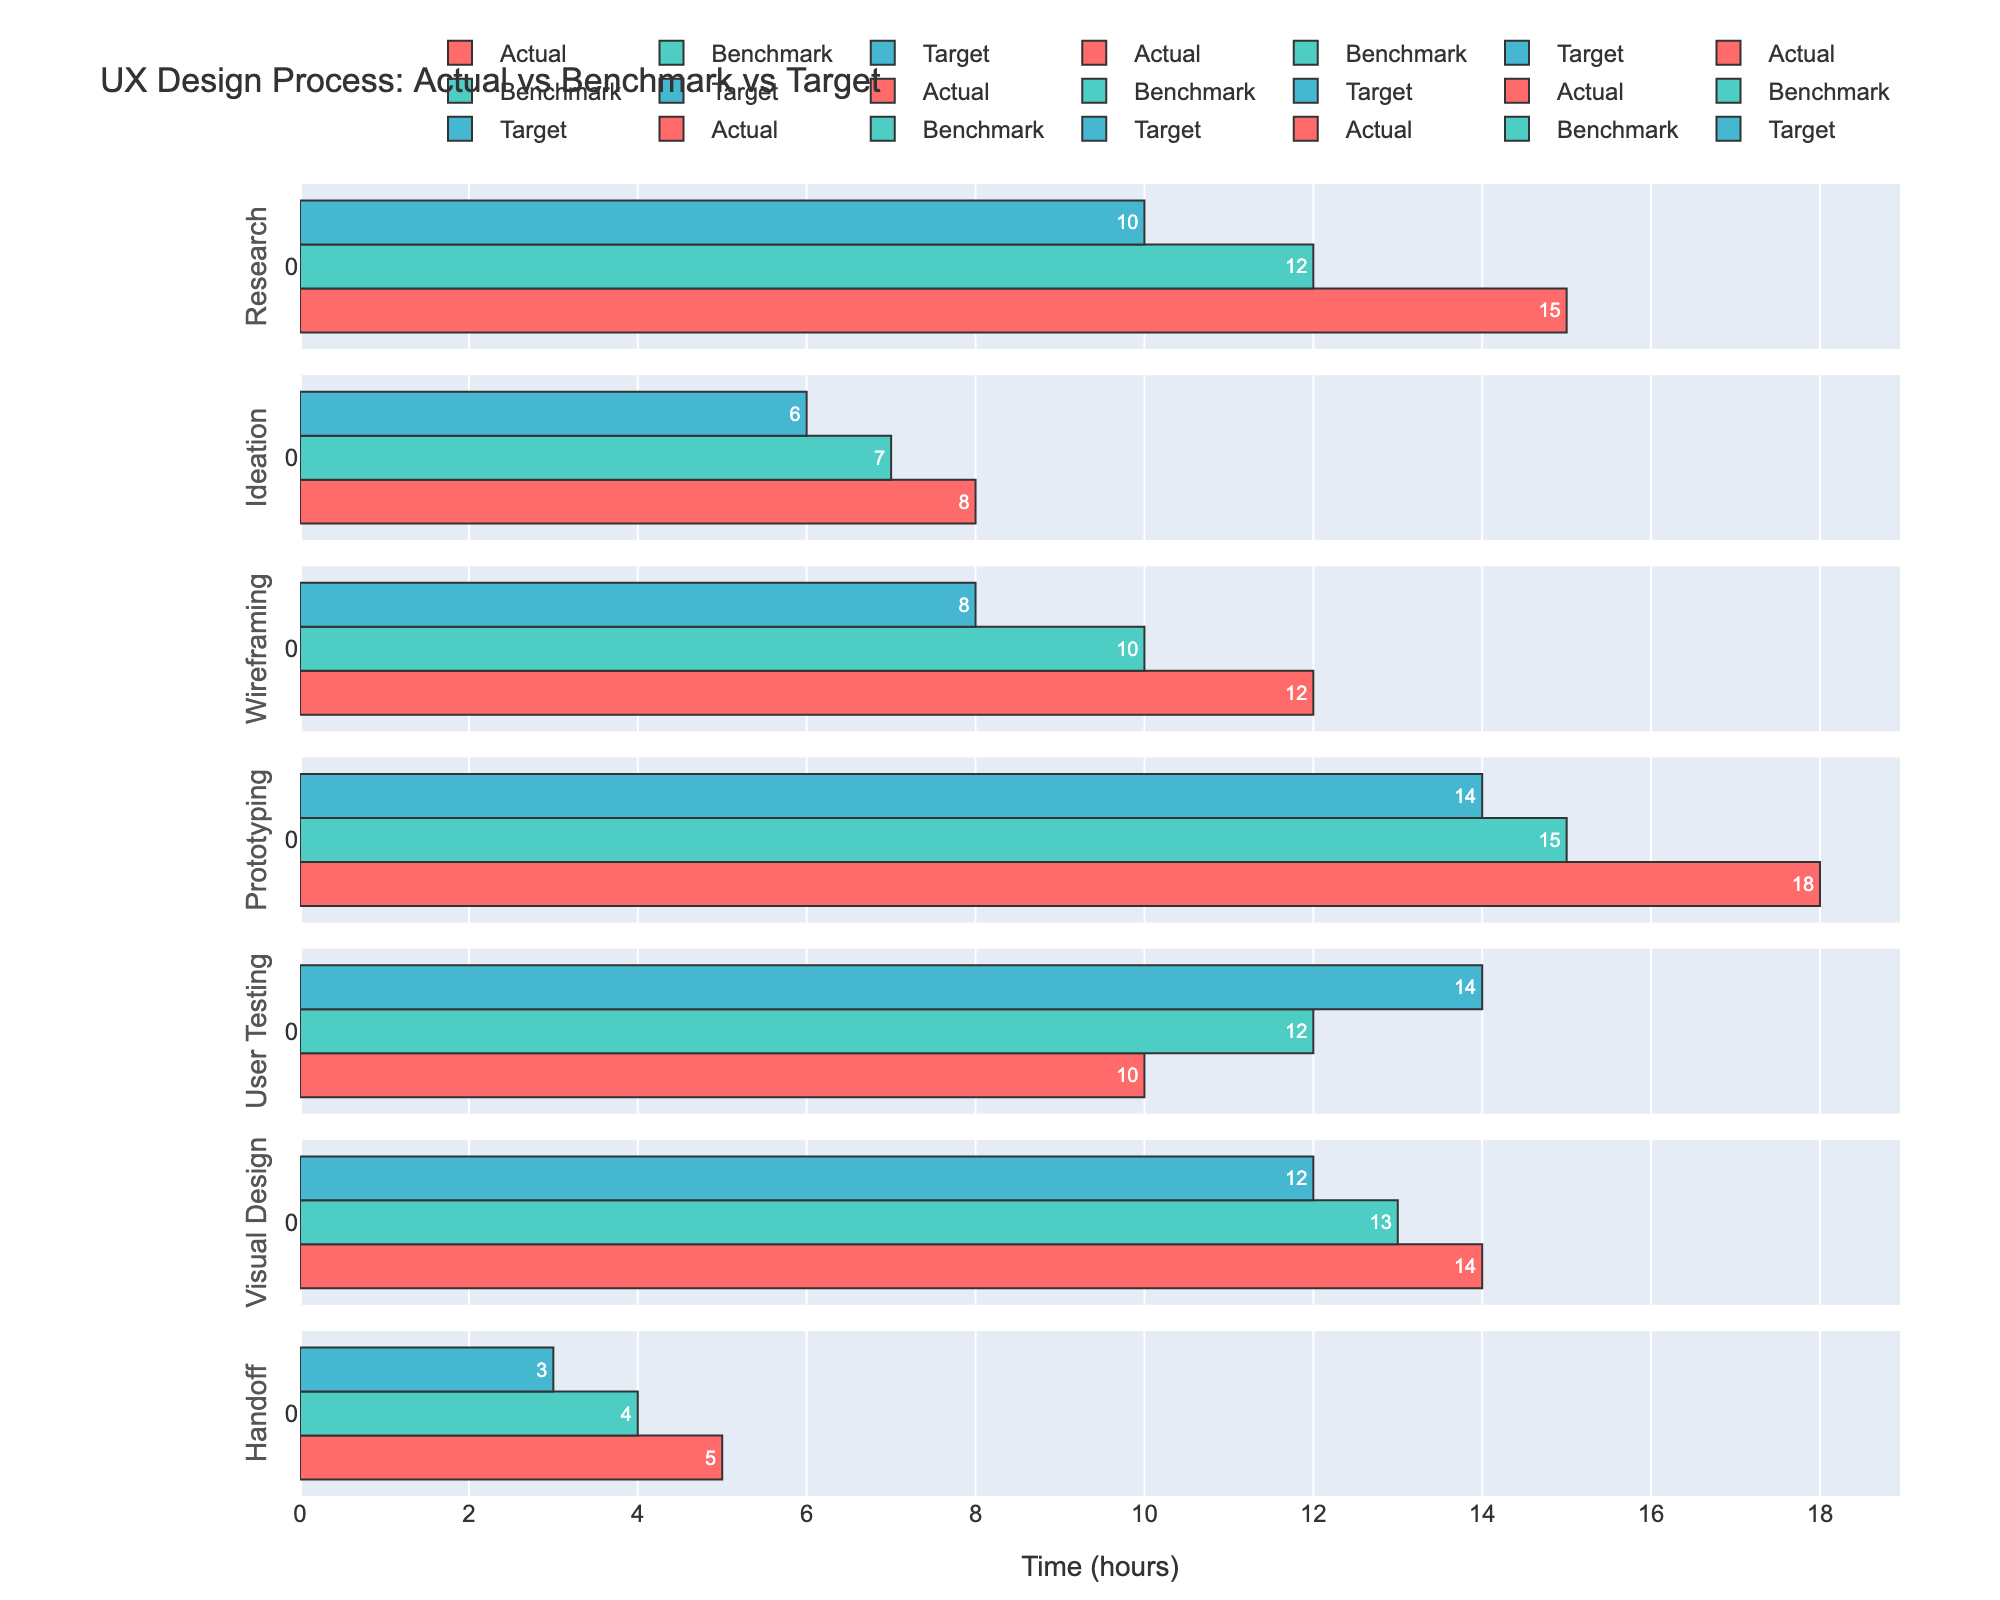What is the title of the figure? The title is usually located at the top of the figure. It's important to read it to understand what the entire figure represents.
Answer: UX Design Process: Actual vs Benchmark vs Target Which phase shows the highest "Actual" time spent? Look for the longest bar colored in the first color of the custom palette. The phase corresponding to this bar indicates the highest "Actual" time spent.
Answer: Prototyping How much time is spent on the User Testing phase compared to its Benchmark value? Identify the lengths of the bars for "User Testing" in both the "Actual" and "Benchmark" categories. Find the difference between these two values.
Answer: -2 hours Which phase has the biggest gap between Actual and Target values? For each phase, calculate the difference between the "Actual" and "Target" values. Identify the phase with the largest positive difference.
Answer: Prototyping Is there any phase where the Actual time is lower than the Benchmark time? Compare the bars in the "Actual" and "Benchmark" categories for each phase to check if any "Actual" time is less than the "Benchmark" time.
Answer: No During which phase is the Actual time equal to the Target time? Compare the bars labeled "Actual" and "Target" for each phase and check if any of them have the same value.
Answer: None Which phase's "Target" value is closest to its "Benchmark" value? Calculate the absolute difference between "Target" and "Benchmark" for each phase. The phase with the smallest difference has the closest values.
Answer: Visual Design What is the total time spent on the Ideation and Wireframing phases according to the Benchmark values? Sum the Benchmark values for the Ideation (7) and Wireframing (10) phases.
Answer: 17 hours How does the time spent on Research compare to the industry Benchmark? Identify the values for "Research" in the "Actual" and "Benchmark" categories and compare them to see if the "Actual" time is higher or lower.
Answer: Higher Which phase shows the least Actual time? Look for the shortest bar in the "Actual" category. The phase corresponding to this bar shows the least time spent.
Answer: Handoff 